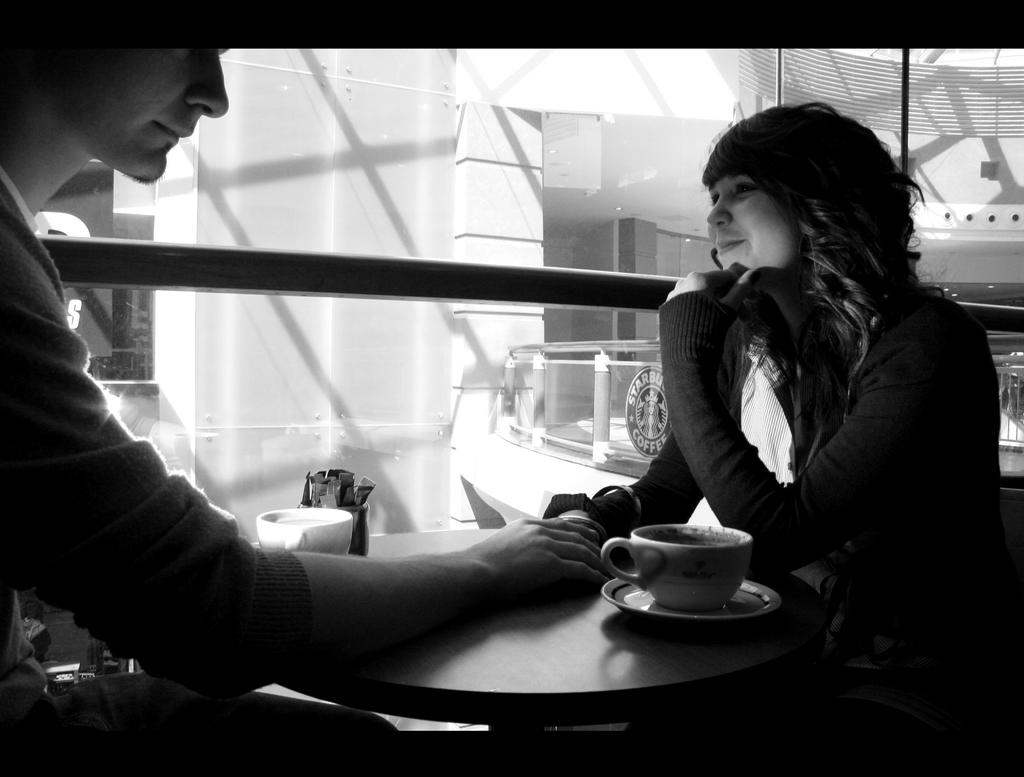Who is present in the image? There is a man and a woman in the image. What are the man and woman doing in the image? The man and woman are sitting on chairs. What objects can be seen on the table in the image? There is a cup, a saucer, a box, and a glass on the table. What is visible in the background of the image? There is a building in the background of the image. How many rods are being used by the deer in the image? There are no deer or rods present in the image. What type of cup is the deer holding in the image? There is no deer or cup held by a deer in the image. 